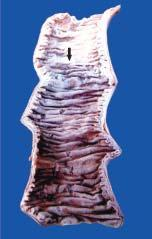what separates infarcted area from the normal bowel?
Answer the question using a single word or phrase. A sharp line of demarcation 